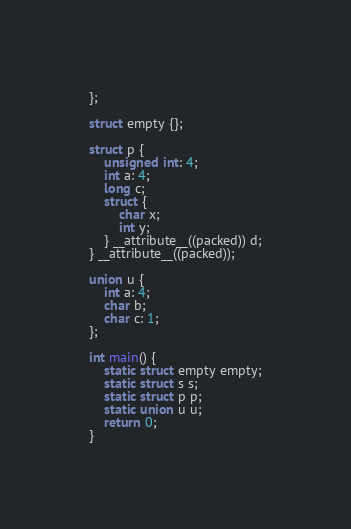Convert code to text. <code><loc_0><loc_0><loc_500><loc_500><_C_>};

struct empty {};

struct p {
	unsigned int: 4;
	int a: 4;
	long c;
	struct {
		char x;
		int y;
	} __attribute__((packed)) d;
} __attribute__((packed));

union u {
	int a: 4;
	char b;
	char c: 1;
};

int main() {
	static struct empty empty;
	static struct s s;
	static struct p p;
	static union u u;
	return 0;
}
</code> 